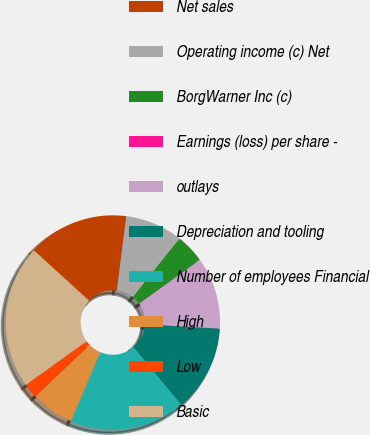Convert chart. <chart><loc_0><loc_0><loc_500><loc_500><pie_chart><fcel>Net sales<fcel>Operating income (c) Net<fcel>BorgWarner Inc (c)<fcel>Earnings (loss) per share -<fcel>outlays<fcel>Depreciation and tooling<fcel>Number of employees Financial<fcel>High<fcel>Low<fcel>Basic<nl><fcel>15.23%<fcel>8.7%<fcel>4.35%<fcel>0.0%<fcel>10.88%<fcel>13.05%<fcel>17.4%<fcel>6.53%<fcel>2.18%<fcel>21.68%<nl></chart> 